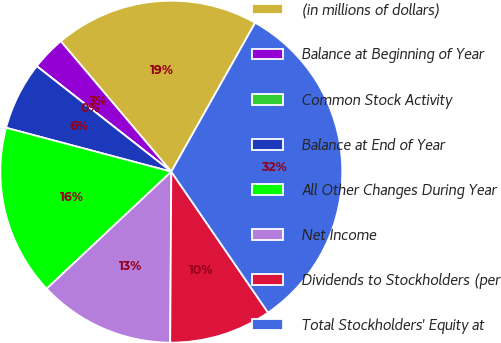Convert chart. <chart><loc_0><loc_0><loc_500><loc_500><pie_chart><fcel>(in millions of dollars)<fcel>Balance at Beginning of Year<fcel>Common Stock Activity<fcel>Balance at End of Year<fcel>All Other Changes During Year<fcel>Net Income<fcel>Dividends to Stockholders (per<fcel>Total Stockholders' Equity at<nl><fcel>19.35%<fcel>3.23%<fcel>0.0%<fcel>6.45%<fcel>16.13%<fcel>12.9%<fcel>9.68%<fcel>32.26%<nl></chart> 